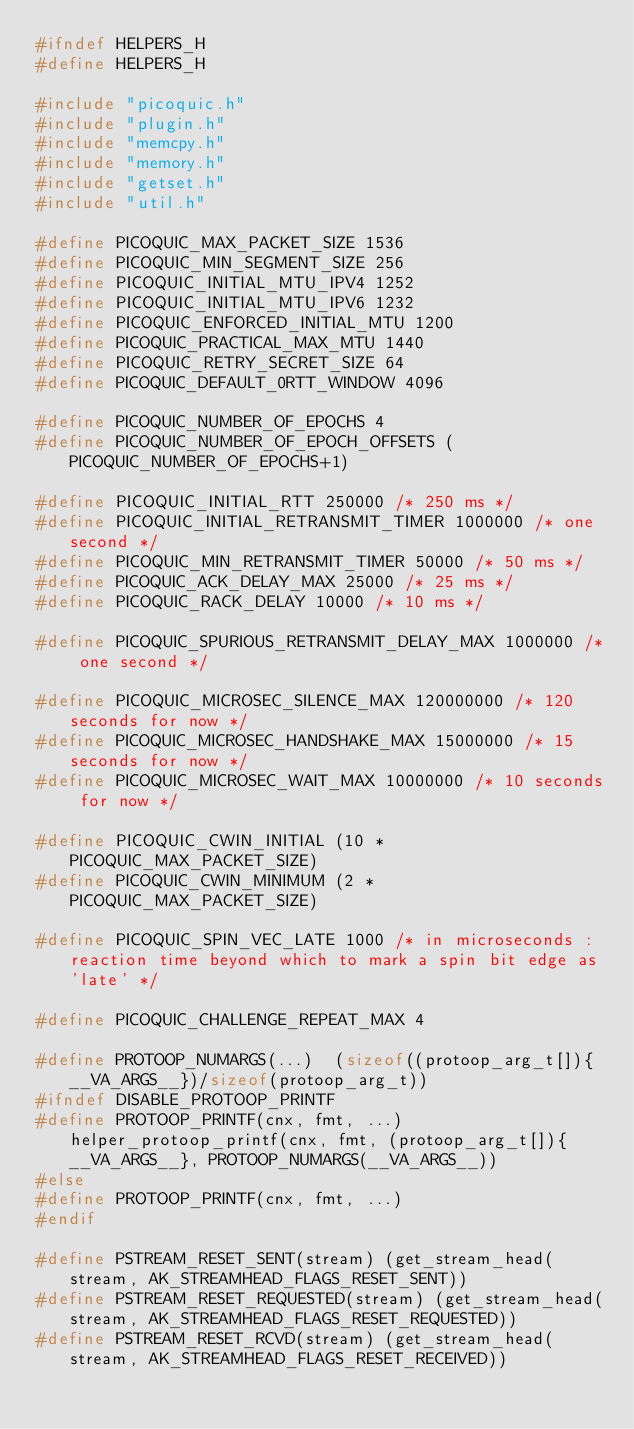Convert code to text. <code><loc_0><loc_0><loc_500><loc_500><_C_>#ifndef HELPERS_H
#define HELPERS_H

#include "picoquic.h"
#include "plugin.h"
#include "memcpy.h"
#include "memory.h"
#include "getset.h"
#include "util.h"

#define PICOQUIC_MAX_PACKET_SIZE 1536
#define PICOQUIC_MIN_SEGMENT_SIZE 256
#define PICOQUIC_INITIAL_MTU_IPV4 1252
#define PICOQUIC_INITIAL_MTU_IPV6 1232
#define PICOQUIC_ENFORCED_INITIAL_MTU 1200
#define PICOQUIC_PRACTICAL_MAX_MTU 1440
#define PICOQUIC_RETRY_SECRET_SIZE 64
#define PICOQUIC_DEFAULT_0RTT_WINDOW 4096

#define PICOQUIC_NUMBER_OF_EPOCHS 4
#define PICOQUIC_NUMBER_OF_EPOCH_OFFSETS (PICOQUIC_NUMBER_OF_EPOCHS+1)

#define PICOQUIC_INITIAL_RTT 250000 /* 250 ms */
#define PICOQUIC_INITIAL_RETRANSMIT_TIMER 1000000 /* one second */
#define PICOQUIC_MIN_RETRANSMIT_TIMER 50000 /* 50 ms */
#define PICOQUIC_ACK_DELAY_MAX 25000 /* 25 ms */
#define PICOQUIC_RACK_DELAY 10000 /* 10 ms */

#define PICOQUIC_SPURIOUS_RETRANSMIT_DELAY_MAX 1000000 /* one second */

#define PICOQUIC_MICROSEC_SILENCE_MAX 120000000 /* 120 seconds for now */
#define PICOQUIC_MICROSEC_HANDSHAKE_MAX 15000000 /* 15 seconds for now */
#define PICOQUIC_MICROSEC_WAIT_MAX 10000000 /* 10 seconds for now */

#define PICOQUIC_CWIN_INITIAL (10 * PICOQUIC_MAX_PACKET_SIZE)
#define PICOQUIC_CWIN_MINIMUM (2 * PICOQUIC_MAX_PACKET_SIZE)

#define PICOQUIC_SPIN_VEC_LATE 1000 /* in microseconds : reaction time beyond which to mark a spin bit edge as 'late' */

#define PICOQUIC_CHALLENGE_REPEAT_MAX 4

#define PROTOOP_NUMARGS(...)  (sizeof((protoop_arg_t[]){__VA_ARGS__})/sizeof(protoop_arg_t))
#ifndef DISABLE_PROTOOP_PRINTF
#define PROTOOP_PRINTF(cnx, fmt, ...)   helper_protoop_printf(cnx, fmt, (protoop_arg_t[]){__VA_ARGS__}, PROTOOP_NUMARGS(__VA_ARGS__))
#else
#define PROTOOP_PRINTF(cnx, fmt, ...)
#endif

#define PSTREAM_RESET_SENT(stream) (get_stream_head(stream, AK_STREAMHEAD_FLAGS_RESET_SENT))
#define PSTREAM_RESET_REQUESTED(stream) (get_stream_head(stream, AK_STREAMHEAD_FLAGS_RESET_REQUESTED))
#define PSTREAM_RESET_RCVD(stream) (get_stream_head(stream, AK_STREAMHEAD_FLAGS_RESET_RECEIVED))</code> 